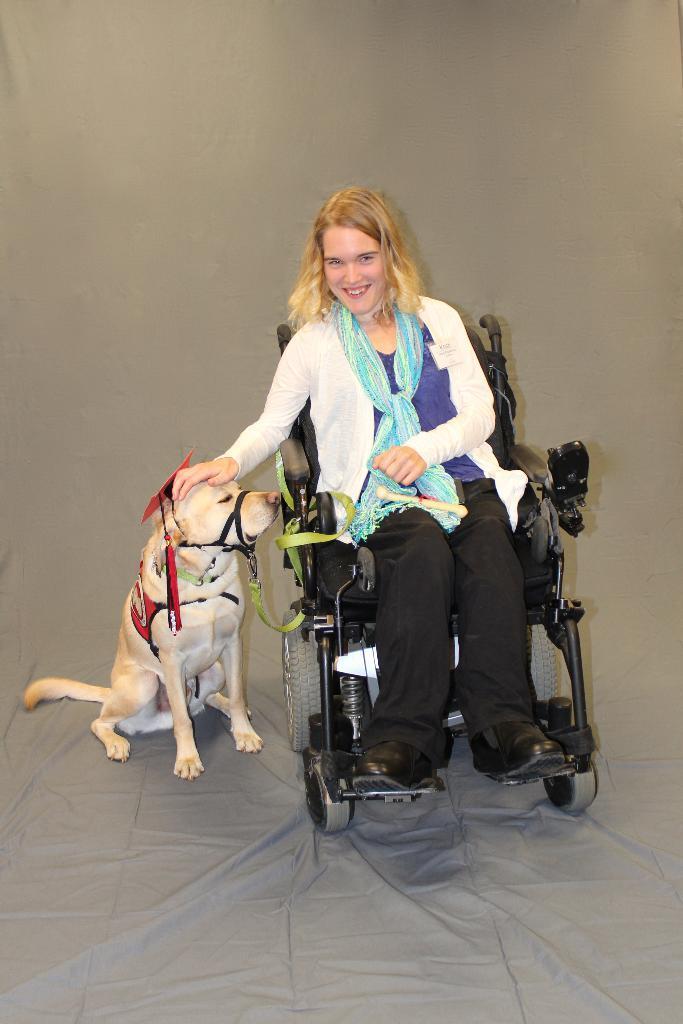Can you describe this image briefly? This woman is smiling and sitting on a wheelchair. Beside this woman there is a dog. This woman kept her hand on dog head. Background it is in gray color.  